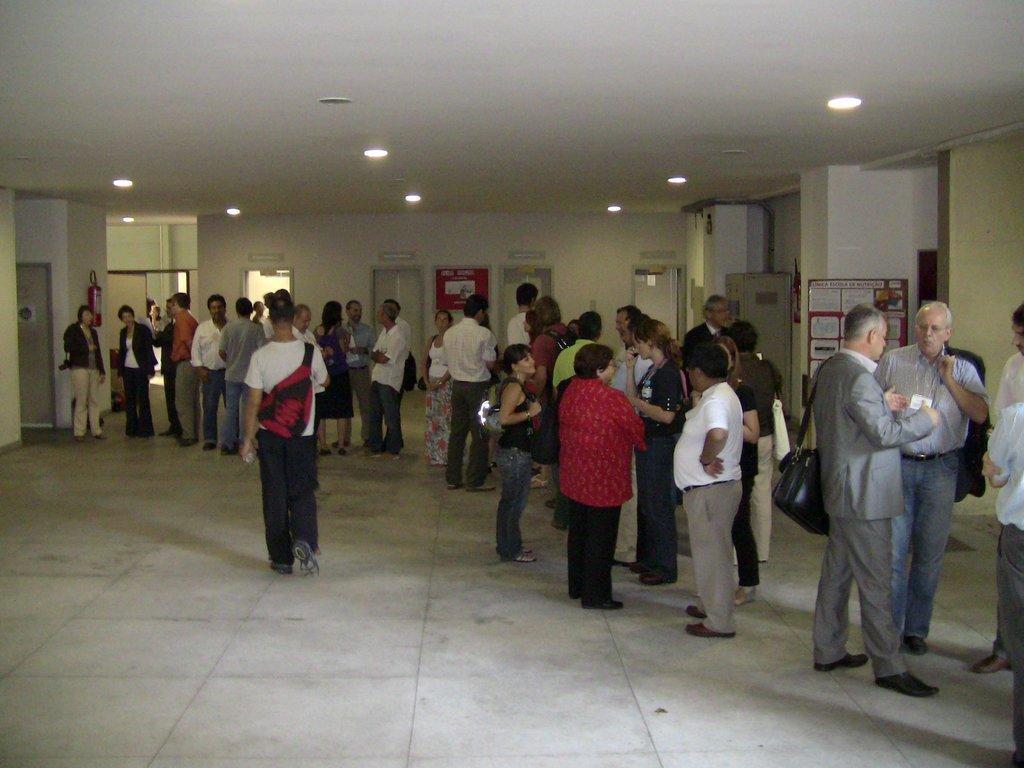Could you give a brief overview of what you see in this image? It is a picture inside of a room. In this picture I can see ceiling lights, people, doors, walls, fire extinguisher, boards and things.   